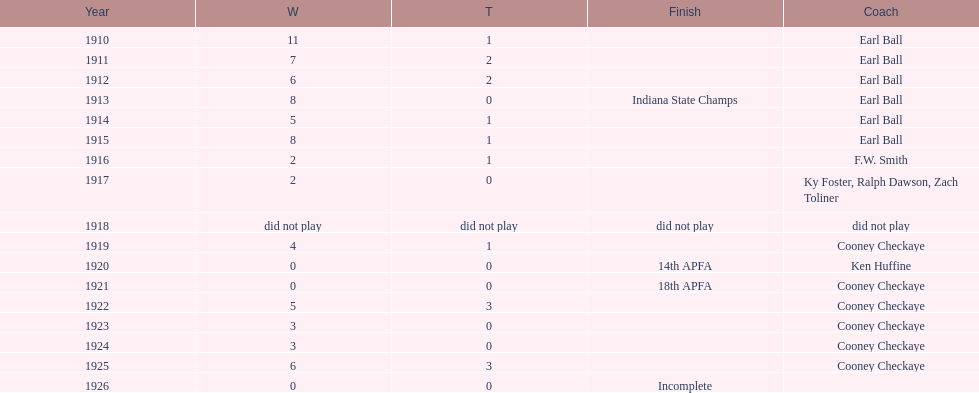The muncie flyers participated from 1910 to 1925, except for one year. in which year did the flyers not compete? 1918. 